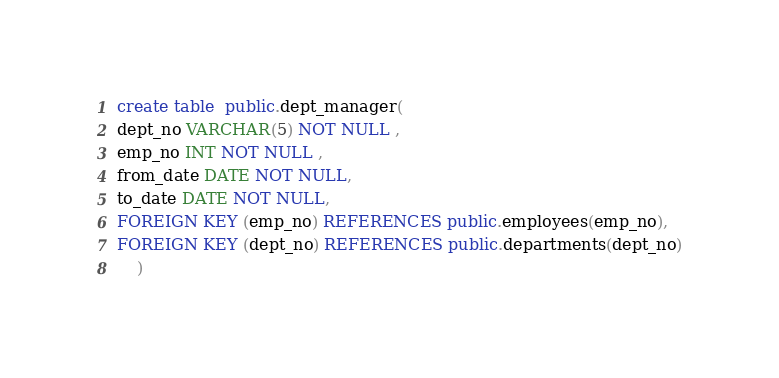Convert code to text. <code><loc_0><loc_0><loc_500><loc_500><_SQL_>create table  public.dept_manager(
dept_no VARCHAR(5) NOT NULL ,
emp_no INT NOT NULL ,
from_date DATE NOT NULL,
to_date DATE NOT NULL,
FOREIGN KEY (emp_no) REFERENCES public.employees(emp_no),
FOREIGN KEY (dept_no) REFERENCES public.departments(dept_no)
	)</code> 